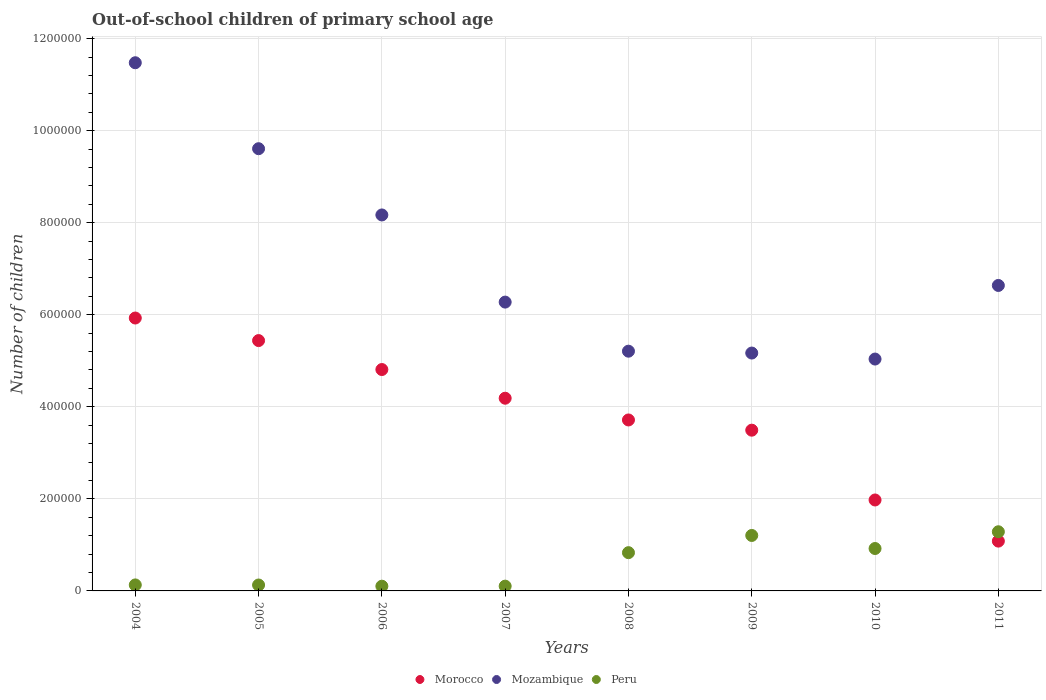How many different coloured dotlines are there?
Your answer should be compact. 3. Is the number of dotlines equal to the number of legend labels?
Keep it short and to the point. Yes. What is the number of out-of-school children in Peru in 2007?
Ensure brevity in your answer.  1.04e+04. Across all years, what is the maximum number of out-of-school children in Peru?
Keep it short and to the point. 1.29e+05. Across all years, what is the minimum number of out-of-school children in Mozambique?
Keep it short and to the point. 5.04e+05. In which year was the number of out-of-school children in Peru maximum?
Provide a short and direct response. 2011. In which year was the number of out-of-school children in Mozambique minimum?
Make the answer very short. 2010. What is the total number of out-of-school children in Mozambique in the graph?
Your answer should be very brief. 5.76e+06. What is the difference between the number of out-of-school children in Morocco in 2004 and that in 2011?
Your answer should be very brief. 4.85e+05. What is the difference between the number of out-of-school children in Morocco in 2007 and the number of out-of-school children in Peru in 2008?
Keep it short and to the point. 3.36e+05. What is the average number of out-of-school children in Mozambique per year?
Your answer should be compact. 7.20e+05. In the year 2011, what is the difference between the number of out-of-school children in Peru and number of out-of-school children in Mozambique?
Offer a very short reply. -5.35e+05. In how many years, is the number of out-of-school children in Morocco greater than 520000?
Keep it short and to the point. 2. What is the ratio of the number of out-of-school children in Peru in 2005 to that in 2007?
Provide a short and direct response. 1.24. Is the difference between the number of out-of-school children in Peru in 2004 and 2009 greater than the difference between the number of out-of-school children in Mozambique in 2004 and 2009?
Offer a very short reply. No. What is the difference between the highest and the second highest number of out-of-school children in Morocco?
Your answer should be compact. 4.90e+04. What is the difference between the highest and the lowest number of out-of-school children in Peru?
Your answer should be very brief. 1.18e+05. In how many years, is the number of out-of-school children in Peru greater than the average number of out-of-school children in Peru taken over all years?
Ensure brevity in your answer.  4. Is the sum of the number of out-of-school children in Morocco in 2006 and 2010 greater than the maximum number of out-of-school children in Mozambique across all years?
Ensure brevity in your answer.  No. Is it the case that in every year, the sum of the number of out-of-school children in Peru and number of out-of-school children in Morocco  is greater than the number of out-of-school children in Mozambique?
Offer a terse response. No. Does the number of out-of-school children in Mozambique monotonically increase over the years?
Provide a short and direct response. No. Is the number of out-of-school children in Morocco strictly greater than the number of out-of-school children in Mozambique over the years?
Give a very brief answer. No. Is the number of out-of-school children in Morocco strictly less than the number of out-of-school children in Mozambique over the years?
Your answer should be compact. Yes. What is the difference between two consecutive major ticks on the Y-axis?
Keep it short and to the point. 2.00e+05. Does the graph contain any zero values?
Your answer should be very brief. No. Does the graph contain grids?
Your answer should be very brief. Yes. How many legend labels are there?
Ensure brevity in your answer.  3. How are the legend labels stacked?
Ensure brevity in your answer.  Horizontal. What is the title of the graph?
Offer a terse response. Out-of-school children of primary school age. What is the label or title of the X-axis?
Give a very brief answer. Years. What is the label or title of the Y-axis?
Offer a terse response. Number of children. What is the Number of children in Morocco in 2004?
Make the answer very short. 5.93e+05. What is the Number of children of Mozambique in 2004?
Ensure brevity in your answer.  1.15e+06. What is the Number of children of Peru in 2004?
Give a very brief answer. 1.30e+04. What is the Number of children in Morocco in 2005?
Give a very brief answer. 5.44e+05. What is the Number of children in Mozambique in 2005?
Provide a succinct answer. 9.61e+05. What is the Number of children of Peru in 2005?
Your answer should be very brief. 1.28e+04. What is the Number of children in Morocco in 2006?
Your response must be concise. 4.81e+05. What is the Number of children in Mozambique in 2006?
Provide a succinct answer. 8.17e+05. What is the Number of children in Peru in 2006?
Ensure brevity in your answer.  1.03e+04. What is the Number of children in Morocco in 2007?
Offer a very short reply. 4.19e+05. What is the Number of children of Mozambique in 2007?
Your answer should be very brief. 6.28e+05. What is the Number of children of Peru in 2007?
Make the answer very short. 1.04e+04. What is the Number of children in Morocco in 2008?
Provide a short and direct response. 3.71e+05. What is the Number of children of Mozambique in 2008?
Your answer should be very brief. 5.21e+05. What is the Number of children of Peru in 2008?
Your answer should be very brief. 8.31e+04. What is the Number of children in Morocco in 2009?
Your response must be concise. 3.49e+05. What is the Number of children of Mozambique in 2009?
Give a very brief answer. 5.17e+05. What is the Number of children of Peru in 2009?
Provide a short and direct response. 1.21e+05. What is the Number of children of Morocco in 2010?
Make the answer very short. 1.98e+05. What is the Number of children of Mozambique in 2010?
Keep it short and to the point. 5.04e+05. What is the Number of children of Peru in 2010?
Your response must be concise. 9.21e+04. What is the Number of children in Morocco in 2011?
Ensure brevity in your answer.  1.08e+05. What is the Number of children of Mozambique in 2011?
Offer a terse response. 6.64e+05. What is the Number of children in Peru in 2011?
Offer a terse response. 1.29e+05. Across all years, what is the maximum Number of children of Morocco?
Offer a very short reply. 5.93e+05. Across all years, what is the maximum Number of children in Mozambique?
Give a very brief answer. 1.15e+06. Across all years, what is the maximum Number of children in Peru?
Offer a terse response. 1.29e+05. Across all years, what is the minimum Number of children of Morocco?
Make the answer very short. 1.08e+05. Across all years, what is the minimum Number of children of Mozambique?
Your answer should be compact. 5.04e+05. Across all years, what is the minimum Number of children of Peru?
Offer a very short reply. 1.03e+04. What is the total Number of children of Morocco in the graph?
Your answer should be very brief. 3.06e+06. What is the total Number of children of Mozambique in the graph?
Make the answer very short. 5.76e+06. What is the total Number of children of Peru in the graph?
Provide a short and direct response. 4.71e+05. What is the difference between the Number of children in Morocco in 2004 and that in 2005?
Make the answer very short. 4.90e+04. What is the difference between the Number of children of Mozambique in 2004 and that in 2005?
Offer a terse response. 1.87e+05. What is the difference between the Number of children of Peru in 2004 and that in 2005?
Keep it short and to the point. 190. What is the difference between the Number of children of Morocco in 2004 and that in 2006?
Provide a succinct answer. 1.12e+05. What is the difference between the Number of children in Mozambique in 2004 and that in 2006?
Provide a short and direct response. 3.31e+05. What is the difference between the Number of children in Peru in 2004 and that in 2006?
Your response must be concise. 2781. What is the difference between the Number of children in Morocco in 2004 and that in 2007?
Make the answer very short. 1.74e+05. What is the difference between the Number of children in Mozambique in 2004 and that in 2007?
Your answer should be very brief. 5.20e+05. What is the difference between the Number of children of Peru in 2004 and that in 2007?
Your response must be concise. 2645. What is the difference between the Number of children in Morocco in 2004 and that in 2008?
Keep it short and to the point. 2.21e+05. What is the difference between the Number of children in Mozambique in 2004 and that in 2008?
Make the answer very short. 6.27e+05. What is the difference between the Number of children in Peru in 2004 and that in 2008?
Your answer should be compact. -7.01e+04. What is the difference between the Number of children of Morocco in 2004 and that in 2009?
Offer a very short reply. 2.44e+05. What is the difference between the Number of children of Mozambique in 2004 and that in 2009?
Provide a short and direct response. 6.31e+05. What is the difference between the Number of children of Peru in 2004 and that in 2009?
Your answer should be compact. -1.07e+05. What is the difference between the Number of children of Morocco in 2004 and that in 2010?
Your answer should be compact. 3.95e+05. What is the difference between the Number of children in Mozambique in 2004 and that in 2010?
Offer a terse response. 6.44e+05. What is the difference between the Number of children of Peru in 2004 and that in 2010?
Offer a terse response. -7.91e+04. What is the difference between the Number of children in Morocco in 2004 and that in 2011?
Your response must be concise. 4.85e+05. What is the difference between the Number of children of Mozambique in 2004 and that in 2011?
Make the answer very short. 4.84e+05. What is the difference between the Number of children in Peru in 2004 and that in 2011?
Offer a very short reply. -1.15e+05. What is the difference between the Number of children in Morocco in 2005 and that in 2006?
Offer a terse response. 6.29e+04. What is the difference between the Number of children of Mozambique in 2005 and that in 2006?
Your response must be concise. 1.44e+05. What is the difference between the Number of children in Peru in 2005 and that in 2006?
Give a very brief answer. 2591. What is the difference between the Number of children of Morocco in 2005 and that in 2007?
Your answer should be compact. 1.25e+05. What is the difference between the Number of children of Mozambique in 2005 and that in 2007?
Your answer should be compact. 3.33e+05. What is the difference between the Number of children of Peru in 2005 and that in 2007?
Offer a very short reply. 2455. What is the difference between the Number of children in Morocco in 2005 and that in 2008?
Provide a short and direct response. 1.72e+05. What is the difference between the Number of children in Mozambique in 2005 and that in 2008?
Make the answer very short. 4.40e+05. What is the difference between the Number of children of Peru in 2005 and that in 2008?
Your response must be concise. -7.03e+04. What is the difference between the Number of children of Morocco in 2005 and that in 2009?
Your answer should be very brief. 1.95e+05. What is the difference between the Number of children of Mozambique in 2005 and that in 2009?
Offer a very short reply. 4.44e+05. What is the difference between the Number of children in Peru in 2005 and that in 2009?
Offer a terse response. -1.08e+05. What is the difference between the Number of children in Morocco in 2005 and that in 2010?
Your response must be concise. 3.46e+05. What is the difference between the Number of children of Mozambique in 2005 and that in 2010?
Make the answer very short. 4.57e+05. What is the difference between the Number of children in Peru in 2005 and that in 2010?
Your answer should be very brief. -7.93e+04. What is the difference between the Number of children in Morocco in 2005 and that in 2011?
Give a very brief answer. 4.36e+05. What is the difference between the Number of children in Mozambique in 2005 and that in 2011?
Give a very brief answer. 2.97e+05. What is the difference between the Number of children in Peru in 2005 and that in 2011?
Offer a terse response. -1.16e+05. What is the difference between the Number of children of Morocco in 2006 and that in 2007?
Offer a terse response. 6.23e+04. What is the difference between the Number of children of Mozambique in 2006 and that in 2007?
Ensure brevity in your answer.  1.89e+05. What is the difference between the Number of children in Peru in 2006 and that in 2007?
Your response must be concise. -136. What is the difference between the Number of children of Morocco in 2006 and that in 2008?
Give a very brief answer. 1.10e+05. What is the difference between the Number of children of Mozambique in 2006 and that in 2008?
Offer a very short reply. 2.96e+05. What is the difference between the Number of children of Peru in 2006 and that in 2008?
Provide a short and direct response. -7.29e+04. What is the difference between the Number of children of Morocco in 2006 and that in 2009?
Offer a very short reply. 1.32e+05. What is the difference between the Number of children in Mozambique in 2006 and that in 2009?
Give a very brief answer. 3.00e+05. What is the difference between the Number of children of Peru in 2006 and that in 2009?
Offer a terse response. -1.10e+05. What is the difference between the Number of children in Morocco in 2006 and that in 2010?
Provide a succinct answer. 2.83e+05. What is the difference between the Number of children of Mozambique in 2006 and that in 2010?
Offer a terse response. 3.13e+05. What is the difference between the Number of children in Peru in 2006 and that in 2010?
Provide a succinct answer. -8.19e+04. What is the difference between the Number of children in Morocco in 2006 and that in 2011?
Give a very brief answer. 3.73e+05. What is the difference between the Number of children in Mozambique in 2006 and that in 2011?
Provide a succinct answer. 1.53e+05. What is the difference between the Number of children of Peru in 2006 and that in 2011?
Offer a very short reply. -1.18e+05. What is the difference between the Number of children of Morocco in 2007 and that in 2008?
Make the answer very short. 4.72e+04. What is the difference between the Number of children in Mozambique in 2007 and that in 2008?
Keep it short and to the point. 1.07e+05. What is the difference between the Number of children of Peru in 2007 and that in 2008?
Your answer should be very brief. -7.27e+04. What is the difference between the Number of children of Morocco in 2007 and that in 2009?
Provide a short and direct response. 6.94e+04. What is the difference between the Number of children in Mozambique in 2007 and that in 2009?
Keep it short and to the point. 1.11e+05. What is the difference between the Number of children in Peru in 2007 and that in 2009?
Ensure brevity in your answer.  -1.10e+05. What is the difference between the Number of children of Morocco in 2007 and that in 2010?
Offer a terse response. 2.21e+05. What is the difference between the Number of children in Mozambique in 2007 and that in 2010?
Your answer should be compact. 1.24e+05. What is the difference between the Number of children in Peru in 2007 and that in 2010?
Provide a short and direct response. -8.18e+04. What is the difference between the Number of children in Morocco in 2007 and that in 2011?
Provide a succinct answer. 3.10e+05. What is the difference between the Number of children of Mozambique in 2007 and that in 2011?
Your response must be concise. -3.62e+04. What is the difference between the Number of children in Peru in 2007 and that in 2011?
Provide a succinct answer. -1.18e+05. What is the difference between the Number of children in Morocco in 2008 and that in 2009?
Give a very brief answer. 2.22e+04. What is the difference between the Number of children of Mozambique in 2008 and that in 2009?
Provide a short and direct response. 4043. What is the difference between the Number of children in Peru in 2008 and that in 2009?
Provide a succinct answer. -3.74e+04. What is the difference between the Number of children in Morocco in 2008 and that in 2010?
Your answer should be compact. 1.74e+05. What is the difference between the Number of children of Mozambique in 2008 and that in 2010?
Provide a succinct answer. 1.71e+04. What is the difference between the Number of children of Peru in 2008 and that in 2010?
Keep it short and to the point. -9027. What is the difference between the Number of children of Morocco in 2008 and that in 2011?
Your response must be concise. 2.63e+05. What is the difference between the Number of children in Mozambique in 2008 and that in 2011?
Your answer should be very brief. -1.43e+05. What is the difference between the Number of children in Peru in 2008 and that in 2011?
Your answer should be very brief. -4.54e+04. What is the difference between the Number of children of Morocco in 2009 and that in 2010?
Offer a very short reply. 1.52e+05. What is the difference between the Number of children of Mozambique in 2009 and that in 2010?
Ensure brevity in your answer.  1.31e+04. What is the difference between the Number of children of Peru in 2009 and that in 2010?
Your response must be concise. 2.84e+04. What is the difference between the Number of children of Morocco in 2009 and that in 2011?
Your answer should be very brief. 2.41e+05. What is the difference between the Number of children in Mozambique in 2009 and that in 2011?
Provide a short and direct response. -1.47e+05. What is the difference between the Number of children in Peru in 2009 and that in 2011?
Your answer should be very brief. -8033. What is the difference between the Number of children of Morocco in 2010 and that in 2011?
Your answer should be very brief. 8.94e+04. What is the difference between the Number of children of Mozambique in 2010 and that in 2011?
Your answer should be compact. -1.60e+05. What is the difference between the Number of children of Peru in 2010 and that in 2011?
Give a very brief answer. -3.64e+04. What is the difference between the Number of children in Morocco in 2004 and the Number of children in Mozambique in 2005?
Provide a succinct answer. -3.68e+05. What is the difference between the Number of children of Morocco in 2004 and the Number of children of Peru in 2005?
Offer a terse response. 5.80e+05. What is the difference between the Number of children of Mozambique in 2004 and the Number of children of Peru in 2005?
Your answer should be compact. 1.13e+06. What is the difference between the Number of children of Morocco in 2004 and the Number of children of Mozambique in 2006?
Provide a succinct answer. -2.24e+05. What is the difference between the Number of children of Morocco in 2004 and the Number of children of Peru in 2006?
Provide a short and direct response. 5.83e+05. What is the difference between the Number of children in Mozambique in 2004 and the Number of children in Peru in 2006?
Provide a short and direct response. 1.14e+06. What is the difference between the Number of children in Morocco in 2004 and the Number of children in Mozambique in 2007?
Offer a very short reply. -3.46e+04. What is the difference between the Number of children of Morocco in 2004 and the Number of children of Peru in 2007?
Your answer should be very brief. 5.83e+05. What is the difference between the Number of children in Mozambique in 2004 and the Number of children in Peru in 2007?
Your response must be concise. 1.14e+06. What is the difference between the Number of children of Morocco in 2004 and the Number of children of Mozambique in 2008?
Your answer should be very brief. 7.21e+04. What is the difference between the Number of children in Morocco in 2004 and the Number of children in Peru in 2008?
Keep it short and to the point. 5.10e+05. What is the difference between the Number of children in Mozambique in 2004 and the Number of children in Peru in 2008?
Ensure brevity in your answer.  1.06e+06. What is the difference between the Number of children of Morocco in 2004 and the Number of children of Mozambique in 2009?
Offer a terse response. 7.61e+04. What is the difference between the Number of children of Morocco in 2004 and the Number of children of Peru in 2009?
Provide a succinct answer. 4.72e+05. What is the difference between the Number of children in Mozambique in 2004 and the Number of children in Peru in 2009?
Offer a terse response. 1.03e+06. What is the difference between the Number of children in Morocco in 2004 and the Number of children in Mozambique in 2010?
Your answer should be very brief. 8.92e+04. What is the difference between the Number of children in Morocco in 2004 and the Number of children in Peru in 2010?
Your answer should be compact. 5.01e+05. What is the difference between the Number of children of Mozambique in 2004 and the Number of children of Peru in 2010?
Your answer should be very brief. 1.06e+06. What is the difference between the Number of children in Morocco in 2004 and the Number of children in Mozambique in 2011?
Your response must be concise. -7.07e+04. What is the difference between the Number of children of Morocco in 2004 and the Number of children of Peru in 2011?
Ensure brevity in your answer.  4.64e+05. What is the difference between the Number of children of Mozambique in 2004 and the Number of children of Peru in 2011?
Your response must be concise. 1.02e+06. What is the difference between the Number of children of Morocco in 2005 and the Number of children of Mozambique in 2006?
Your answer should be compact. -2.73e+05. What is the difference between the Number of children of Morocco in 2005 and the Number of children of Peru in 2006?
Provide a short and direct response. 5.34e+05. What is the difference between the Number of children in Mozambique in 2005 and the Number of children in Peru in 2006?
Your response must be concise. 9.51e+05. What is the difference between the Number of children in Morocco in 2005 and the Number of children in Mozambique in 2007?
Offer a terse response. -8.36e+04. What is the difference between the Number of children in Morocco in 2005 and the Number of children in Peru in 2007?
Provide a succinct answer. 5.34e+05. What is the difference between the Number of children in Mozambique in 2005 and the Number of children in Peru in 2007?
Give a very brief answer. 9.50e+05. What is the difference between the Number of children of Morocco in 2005 and the Number of children of Mozambique in 2008?
Provide a succinct answer. 2.30e+04. What is the difference between the Number of children of Morocco in 2005 and the Number of children of Peru in 2008?
Offer a terse response. 4.61e+05. What is the difference between the Number of children of Mozambique in 2005 and the Number of children of Peru in 2008?
Offer a terse response. 8.78e+05. What is the difference between the Number of children in Morocco in 2005 and the Number of children in Mozambique in 2009?
Your response must be concise. 2.71e+04. What is the difference between the Number of children in Morocco in 2005 and the Number of children in Peru in 2009?
Provide a succinct answer. 4.23e+05. What is the difference between the Number of children of Mozambique in 2005 and the Number of children of Peru in 2009?
Ensure brevity in your answer.  8.40e+05. What is the difference between the Number of children in Morocco in 2005 and the Number of children in Mozambique in 2010?
Offer a terse response. 4.01e+04. What is the difference between the Number of children of Morocco in 2005 and the Number of children of Peru in 2010?
Offer a very short reply. 4.52e+05. What is the difference between the Number of children of Mozambique in 2005 and the Number of children of Peru in 2010?
Offer a terse response. 8.69e+05. What is the difference between the Number of children of Morocco in 2005 and the Number of children of Mozambique in 2011?
Your answer should be very brief. -1.20e+05. What is the difference between the Number of children in Morocco in 2005 and the Number of children in Peru in 2011?
Your answer should be compact. 4.15e+05. What is the difference between the Number of children in Mozambique in 2005 and the Number of children in Peru in 2011?
Your response must be concise. 8.32e+05. What is the difference between the Number of children in Morocco in 2006 and the Number of children in Mozambique in 2007?
Offer a very short reply. -1.47e+05. What is the difference between the Number of children in Morocco in 2006 and the Number of children in Peru in 2007?
Provide a succinct answer. 4.71e+05. What is the difference between the Number of children of Mozambique in 2006 and the Number of children of Peru in 2007?
Make the answer very short. 8.06e+05. What is the difference between the Number of children of Morocco in 2006 and the Number of children of Mozambique in 2008?
Your answer should be very brief. -3.99e+04. What is the difference between the Number of children of Morocco in 2006 and the Number of children of Peru in 2008?
Give a very brief answer. 3.98e+05. What is the difference between the Number of children in Mozambique in 2006 and the Number of children in Peru in 2008?
Your answer should be very brief. 7.34e+05. What is the difference between the Number of children of Morocco in 2006 and the Number of children of Mozambique in 2009?
Ensure brevity in your answer.  -3.58e+04. What is the difference between the Number of children in Morocco in 2006 and the Number of children in Peru in 2009?
Your response must be concise. 3.61e+05. What is the difference between the Number of children of Mozambique in 2006 and the Number of children of Peru in 2009?
Keep it short and to the point. 6.96e+05. What is the difference between the Number of children of Morocco in 2006 and the Number of children of Mozambique in 2010?
Keep it short and to the point. -2.28e+04. What is the difference between the Number of children in Morocco in 2006 and the Number of children in Peru in 2010?
Your response must be concise. 3.89e+05. What is the difference between the Number of children in Mozambique in 2006 and the Number of children in Peru in 2010?
Provide a succinct answer. 7.25e+05. What is the difference between the Number of children in Morocco in 2006 and the Number of children in Mozambique in 2011?
Make the answer very short. -1.83e+05. What is the difference between the Number of children of Morocco in 2006 and the Number of children of Peru in 2011?
Make the answer very short. 3.52e+05. What is the difference between the Number of children of Mozambique in 2006 and the Number of children of Peru in 2011?
Give a very brief answer. 6.88e+05. What is the difference between the Number of children in Morocco in 2007 and the Number of children in Mozambique in 2008?
Give a very brief answer. -1.02e+05. What is the difference between the Number of children of Morocco in 2007 and the Number of children of Peru in 2008?
Your response must be concise. 3.36e+05. What is the difference between the Number of children of Mozambique in 2007 and the Number of children of Peru in 2008?
Provide a succinct answer. 5.44e+05. What is the difference between the Number of children of Morocco in 2007 and the Number of children of Mozambique in 2009?
Your answer should be very brief. -9.82e+04. What is the difference between the Number of children in Morocco in 2007 and the Number of children in Peru in 2009?
Your response must be concise. 2.98e+05. What is the difference between the Number of children in Mozambique in 2007 and the Number of children in Peru in 2009?
Ensure brevity in your answer.  5.07e+05. What is the difference between the Number of children of Morocco in 2007 and the Number of children of Mozambique in 2010?
Offer a terse response. -8.51e+04. What is the difference between the Number of children in Morocco in 2007 and the Number of children in Peru in 2010?
Provide a succinct answer. 3.27e+05. What is the difference between the Number of children in Mozambique in 2007 and the Number of children in Peru in 2010?
Ensure brevity in your answer.  5.35e+05. What is the difference between the Number of children in Morocco in 2007 and the Number of children in Mozambique in 2011?
Give a very brief answer. -2.45e+05. What is the difference between the Number of children in Morocco in 2007 and the Number of children in Peru in 2011?
Make the answer very short. 2.90e+05. What is the difference between the Number of children of Mozambique in 2007 and the Number of children of Peru in 2011?
Your response must be concise. 4.99e+05. What is the difference between the Number of children of Morocco in 2008 and the Number of children of Mozambique in 2009?
Offer a terse response. -1.45e+05. What is the difference between the Number of children of Morocco in 2008 and the Number of children of Peru in 2009?
Keep it short and to the point. 2.51e+05. What is the difference between the Number of children of Mozambique in 2008 and the Number of children of Peru in 2009?
Provide a short and direct response. 4.00e+05. What is the difference between the Number of children in Morocco in 2008 and the Number of children in Mozambique in 2010?
Make the answer very short. -1.32e+05. What is the difference between the Number of children of Morocco in 2008 and the Number of children of Peru in 2010?
Make the answer very short. 2.79e+05. What is the difference between the Number of children of Mozambique in 2008 and the Number of children of Peru in 2010?
Your response must be concise. 4.29e+05. What is the difference between the Number of children of Morocco in 2008 and the Number of children of Mozambique in 2011?
Provide a succinct answer. -2.92e+05. What is the difference between the Number of children in Morocco in 2008 and the Number of children in Peru in 2011?
Offer a very short reply. 2.43e+05. What is the difference between the Number of children of Mozambique in 2008 and the Number of children of Peru in 2011?
Your answer should be compact. 3.92e+05. What is the difference between the Number of children of Morocco in 2009 and the Number of children of Mozambique in 2010?
Make the answer very short. -1.55e+05. What is the difference between the Number of children in Morocco in 2009 and the Number of children in Peru in 2010?
Ensure brevity in your answer.  2.57e+05. What is the difference between the Number of children in Mozambique in 2009 and the Number of children in Peru in 2010?
Your answer should be compact. 4.25e+05. What is the difference between the Number of children of Morocco in 2009 and the Number of children of Mozambique in 2011?
Provide a succinct answer. -3.14e+05. What is the difference between the Number of children of Morocco in 2009 and the Number of children of Peru in 2011?
Ensure brevity in your answer.  2.21e+05. What is the difference between the Number of children of Mozambique in 2009 and the Number of children of Peru in 2011?
Provide a short and direct response. 3.88e+05. What is the difference between the Number of children of Morocco in 2010 and the Number of children of Mozambique in 2011?
Your response must be concise. -4.66e+05. What is the difference between the Number of children in Morocco in 2010 and the Number of children in Peru in 2011?
Give a very brief answer. 6.91e+04. What is the difference between the Number of children in Mozambique in 2010 and the Number of children in Peru in 2011?
Keep it short and to the point. 3.75e+05. What is the average Number of children in Morocco per year?
Provide a succinct answer. 3.83e+05. What is the average Number of children of Mozambique per year?
Make the answer very short. 7.20e+05. What is the average Number of children in Peru per year?
Offer a very short reply. 5.89e+04. In the year 2004, what is the difference between the Number of children of Morocco and Number of children of Mozambique?
Make the answer very short. -5.55e+05. In the year 2004, what is the difference between the Number of children in Morocco and Number of children in Peru?
Your answer should be compact. 5.80e+05. In the year 2004, what is the difference between the Number of children of Mozambique and Number of children of Peru?
Offer a very short reply. 1.13e+06. In the year 2005, what is the difference between the Number of children of Morocco and Number of children of Mozambique?
Your response must be concise. -4.17e+05. In the year 2005, what is the difference between the Number of children of Morocco and Number of children of Peru?
Provide a succinct answer. 5.31e+05. In the year 2005, what is the difference between the Number of children in Mozambique and Number of children in Peru?
Give a very brief answer. 9.48e+05. In the year 2006, what is the difference between the Number of children in Morocco and Number of children in Mozambique?
Keep it short and to the point. -3.36e+05. In the year 2006, what is the difference between the Number of children in Morocco and Number of children in Peru?
Provide a succinct answer. 4.71e+05. In the year 2006, what is the difference between the Number of children of Mozambique and Number of children of Peru?
Provide a succinct answer. 8.07e+05. In the year 2007, what is the difference between the Number of children of Morocco and Number of children of Mozambique?
Keep it short and to the point. -2.09e+05. In the year 2007, what is the difference between the Number of children of Morocco and Number of children of Peru?
Make the answer very short. 4.08e+05. In the year 2007, what is the difference between the Number of children in Mozambique and Number of children in Peru?
Give a very brief answer. 6.17e+05. In the year 2008, what is the difference between the Number of children in Morocco and Number of children in Mozambique?
Offer a very short reply. -1.49e+05. In the year 2008, what is the difference between the Number of children in Morocco and Number of children in Peru?
Make the answer very short. 2.88e+05. In the year 2008, what is the difference between the Number of children in Mozambique and Number of children in Peru?
Provide a short and direct response. 4.38e+05. In the year 2009, what is the difference between the Number of children in Morocco and Number of children in Mozambique?
Offer a terse response. -1.68e+05. In the year 2009, what is the difference between the Number of children in Morocco and Number of children in Peru?
Ensure brevity in your answer.  2.29e+05. In the year 2009, what is the difference between the Number of children in Mozambique and Number of children in Peru?
Offer a terse response. 3.96e+05. In the year 2010, what is the difference between the Number of children of Morocco and Number of children of Mozambique?
Provide a short and direct response. -3.06e+05. In the year 2010, what is the difference between the Number of children in Morocco and Number of children in Peru?
Keep it short and to the point. 1.05e+05. In the year 2010, what is the difference between the Number of children in Mozambique and Number of children in Peru?
Your response must be concise. 4.12e+05. In the year 2011, what is the difference between the Number of children of Morocco and Number of children of Mozambique?
Make the answer very short. -5.55e+05. In the year 2011, what is the difference between the Number of children of Morocco and Number of children of Peru?
Your answer should be very brief. -2.03e+04. In the year 2011, what is the difference between the Number of children in Mozambique and Number of children in Peru?
Your answer should be very brief. 5.35e+05. What is the ratio of the Number of children of Morocco in 2004 to that in 2005?
Keep it short and to the point. 1.09. What is the ratio of the Number of children of Mozambique in 2004 to that in 2005?
Offer a very short reply. 1.19. What is the ratio of the Number of children of Peru in 2004 to that in 2005?
Offer a terse response. 1.01. What is the ratio of the Number of children of Morocco in 2004 to that in 2006?
Your answer should be very brief. 1.23. What is the ratio of the Number of children of Mozambique in 2004 to that in 2006?
Your answer should be very brief. 1.4. What is the ratio of the Number of children in Peru in 2004 to that in 2006?
Make the answer very short. 1.27. What is the ratio of the Number of children of Morocco in 2004 to that in 2007?
Your answer should be very brief. 1.42. What is the ratio of the Number of children of Mozambique in 2004 to that in 2007?
Give a very brief answer. 1.83. What is the ratio of the Number of children of Peru in 2004 to that in 2007?
Make the answer very short. 1.25. What is the ratio of the Number of children of Morocco in 2004 to that in 2008?
Your answer should be very brief. 1.6. What is the ratio of the Number of children in Mozambique in 2004 to that in 2008?
Provide a succinct answer. 2.2. What is the ratio of the Number of children in Peru in 2004 to that in 2008?
Your response must be concise. 0.16. What is the ratio of the Number of children in Morocco in 2004 to that in 2009?
Your answer should be compact. 1.7. What is the ratio of the Number of children in Mozambique in 2004 to that in 2009?
Your answer should be very brief. 2.22. What is the ratio of the Number of children in Peru in 2004 to that in 2009?
Your answer should be compact. 0.11. What is the ratio of the Number of children in Morocco in 2004 to that in 2010?
Ensure brevity in your answer.  3. What is the ratio of the Number of children of Mozambique in 2004 to that in 2010?
Give a very brief answer. 2.28. What is the ratio of the Number of children in Peru in 2004 to that in 2010?
Make the answer very short. 0.14. What is the ratio of the Number of children in Morocco in 2004 to that in 2011?
Give a very brief answer. 5.48. What is the ratio of the Number of children of Mozambique in 2004 to that in 2011?
Make the answer very short. 1.73. What is the ratio of the Number of children in Peru in 2004 to that in 2011?
Keep it short and to the point. 0.1. What is the ratio of the Number of children of Morocco in 2005 to that in 2006?
Give a very brief answer. 1.13. What is the ratio of the Number of children in Mozambique in 2005 to that in 2006?
Your response must be concise. 1.18. What is the ratio of the Number of children of Peru in 2005 to that in 2006?
Your answer should be compact. 1.25. What is the ratio of the Number of children of Morocco in 2005 to that in 2007?
Offer a terse response. 1.3. What is the ratio of the Number of children in Mozambique in 2005 to that in 2007?
Keep it short and to the point. 1.53. What is the ratio of the Number of children in Peru in 2005 to that in 2007?
Make the answer very short. 1.24. What is the ratio of the Number of children of Morocco in 2005 to that in 2008?
Provide a short and direct response. 1.46. What is the ratio of the Number of children of Mozambique in 2005 to that in 2008?
Ensure brevity in your answer.  1.84. What is the ratio of the Number of children in Peru in 2005 to that in 2008?
Offer a terse response. 0.15. What is the ratio of the Number of children in Morocco in 2005 to that in 2009?
Ensure brevity in your answer.  1.56. What is the ratio of the Number of children in Mozambique in 2005 to that in 2009?
Provide a succinct answer. 1.86. What is the ratio of the Number of children of Peru in 2005 to that in 2009?
Your response must be concise. 0.11. What is the ratio of the Number of children in Morocco in 2005 to that in 2010?
Ensure brevity in your answer.  2.75. What is the ratio of the Number of children in Mozambique in 2005 to that in 2010?
Your answer should be compact. 1.91. What is the ratio of the Number of children of Peru in 2005 to that in 2010?
Provide a succinct answer. 0.14. What is the ratio of the Number of children in Morocco in 2005 to that in 2011?
Keep it short and to the point. 5.03. What is the ratio of the Number of children in Mozambique in 2005 to that in 2011?
Offer a terse response. 1.45. What is the ratio of the Number of children in Peru in 2005 to that in 2011?
Your response must be concise. 0.1. What is the ratio of the Number of children in Morocco in 2006 to that in 2007?
Keep it short and to the point. 1.15. What is the ratio of the Number of children in Mozambique in 2006 to that in 2007?
Give a very brief answer. 1.3. What is the ratio of the Number of children in Peru in 2006 to that in 2007?
Your answer should be compact. 0.99. What is the ratio of the Number of children of Morocco in 2006 to that in 2008?
Give a very brief answer. 1.29. What is the ratio of the Number of children of Mozambique in 2006 to that in 2008?
Keep it short and to the point. 1.57. What is the ratio of the Number of children of Peru in 2006 to that in 2008?
Make the answer very short. 0.12. What is the ratio of the Number of children in Morocco in 2006 to that in 2009?
Give a very brief answer. 1.38. What is the ratio of the Number of children in Mozambique in 2006 to that in 2009?
Your answer should be very brief. 1.58. What is the ratio of the Number of children in Peru in 2006 to that in 2009?
Your answer should be very brief. 0.09. What is the ratio of the Number of children in Morocco in 2006 to that in 2010?
Offer a very short reply. 2.43. What is the ratio of the Number of children of Mozambique in 2006 to that in 2010?
Keep it short and to the point. 1.62. What is the ratio of the Number of children in Peru in 2006 to that in 2010?
Give a very brief answer. 0.11. What is the ratio of the Number of children in Morocco in 2006 to that in 2011?
Your answer should be very brief. 4.45. What is the ratio of the Number of children of Mozambique in 2006 to that in 2011?
Your answer should be very brief. 1.23. What is the ratio of the Number of children in Peru in 2006 to that in 2011?
Keep it short and to the point. 0.08. What is the ratio of the Number of children of Morocco in 2007 to that in 2008?
Keep it short and to the point. 1.13. What is the ratio of the Number of children in Mozambique in 2007 to that in 2008?
Make the answer very short. 1.2. What is the ratio of the Number of children of Morocco in 2007 to that in 2009?
Provide a short and direct response. 1.2. What is the ratio of the Number of children in Mozambique in 2007 to that in 2009?
Your answer should be compact. 1.21. What is the ratio of the Number of children of Peru in 2007 to that in 2009?
Provide a succinct answer. 0.09. What is the ratio of the Number of children in Morocco in 2007 to that in 2010?
Provide a succinct answer. 2.12. What is the ratio of the Number of children of Mozambique in 2007 to that in 2010?
Give a very brief answer. 1.25. What is the ratio of the Number of children of Peru in 2007 to that in 2010?
Give a very brief answer. 0.11. What is the ratio of the Number of children in Morocco in 2007 to that in 2011?
Ensure brevity in your answer.  3.87. What is the ratio of the Number of children of Mozambique in 2007 to that in 2011?
Offer a terse response. 0.95. What is the ratio of the Number of children in Peru in 2007 to that in 2011?
Provide a succinct answer. 0.08. What is the ratio of the Number of children of Morocco in 2008 to that in 2009?
Ensure brevity in your answer.  1.06. What is the ratio of the Number of children in Mozambique in 2008 to that in 2009?
Offer a terse response. 1.01. What is the ratio of the Number of children of Peru in 2008 to that in 2009?
Your answer should be very brief. 0.69. What is the ratio of the Number of children of Morocco in 2008 to that in 2010?
Make the answer very short. 1.88. What is the ratio of the Number of children in Mozambique in 2008 to that in 2010?
Make the answer very short. 1.03. What is the ratio of the Number of children in Peru in 2008 to that in 2010?
Your answer should be compact. 0.9. What is the ratio of the Number of children of Morocco in 2008 to that in 2011?
Offer a terse response. 3.43. What is the ratio of the Number of children in Mozambique in 2008 to that in 2011?
Offer a very short reply. 0.78. What is the ratio of the Number of children of Peru in 2008 to that in 2011?
Offer a terse response. 0.65. What is the ratio of the Number of children in Morocco in 2009 to that in 2010?
Your answer should be very brief. 1.77. What is the ratio of the Number of children of Mozambique in 2009 to that in 2010?
Ensure brevity in your answer.  1.03. What is the ratio of the Number of children of Peru in 2009 to that in 2010?
Make the answer very short. 1.31. What is the ratio of the Number of children of Morocco in 2009 to that in 2011?
Your answer should be compact. 3.23. What is the ratio of the Number of children in Mozambique in 2009 to that in 2011?
Your answer should be compact. 0.78. What is the ratio of the Number of children in Morocco in 2010 to that in 2011?
Offer a very short reply. 1.83. What is the ratio of the Number of children of Mozambique in 2010 to that in 2011?
Provide a short and direct response. 0.76. What is the ratio of the Number of children in Peru in 2010 to that in 2011?
Offer a terse response. 0.72. What is the difference between the highest and the second highest Number of children of Morocco?
Offer a very short reply. 4.90e+04. What is the difference between the highest and the second highest Number of children in Mozambique?
Give a very brief answer. 1.87e+05. What is the difference between the highest and the second highest Number of children in Peru?
Keep it short and to the point. 8033. What is the difference between the highest and the lowest Number of children in Morocco?
Ensure brevity in your answer.  4.85e+05. What is the difference between the highest and the lowest Number of children of Mozambique?
Your response must be concise. 6.44e+05. What is the difference between the highest and the lowest Number of children in Peru?
Offer a terse response. 1.18e+05. 